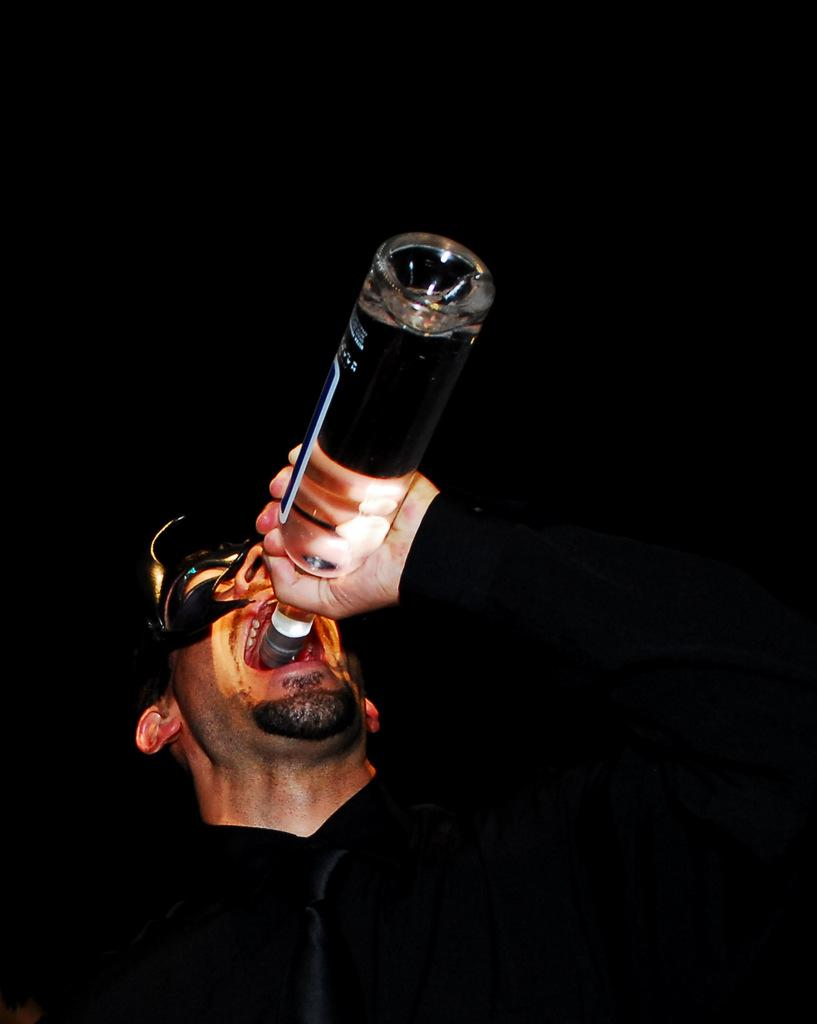What is the main subject of the image? There is a human in the image. What is the human doing in the image? The human is opening his mouth. What is the human holding in the image? The human is holding a bottle. What is inside the bottle? The bottle contains liquid. Is there any additional information about the bottle? Yes, there is a sticker on the bottle. What type of sound can be heard coming from the human in the image? There is no information about any sounds in the image, so it cannot be determined what type of sound might be heard. 